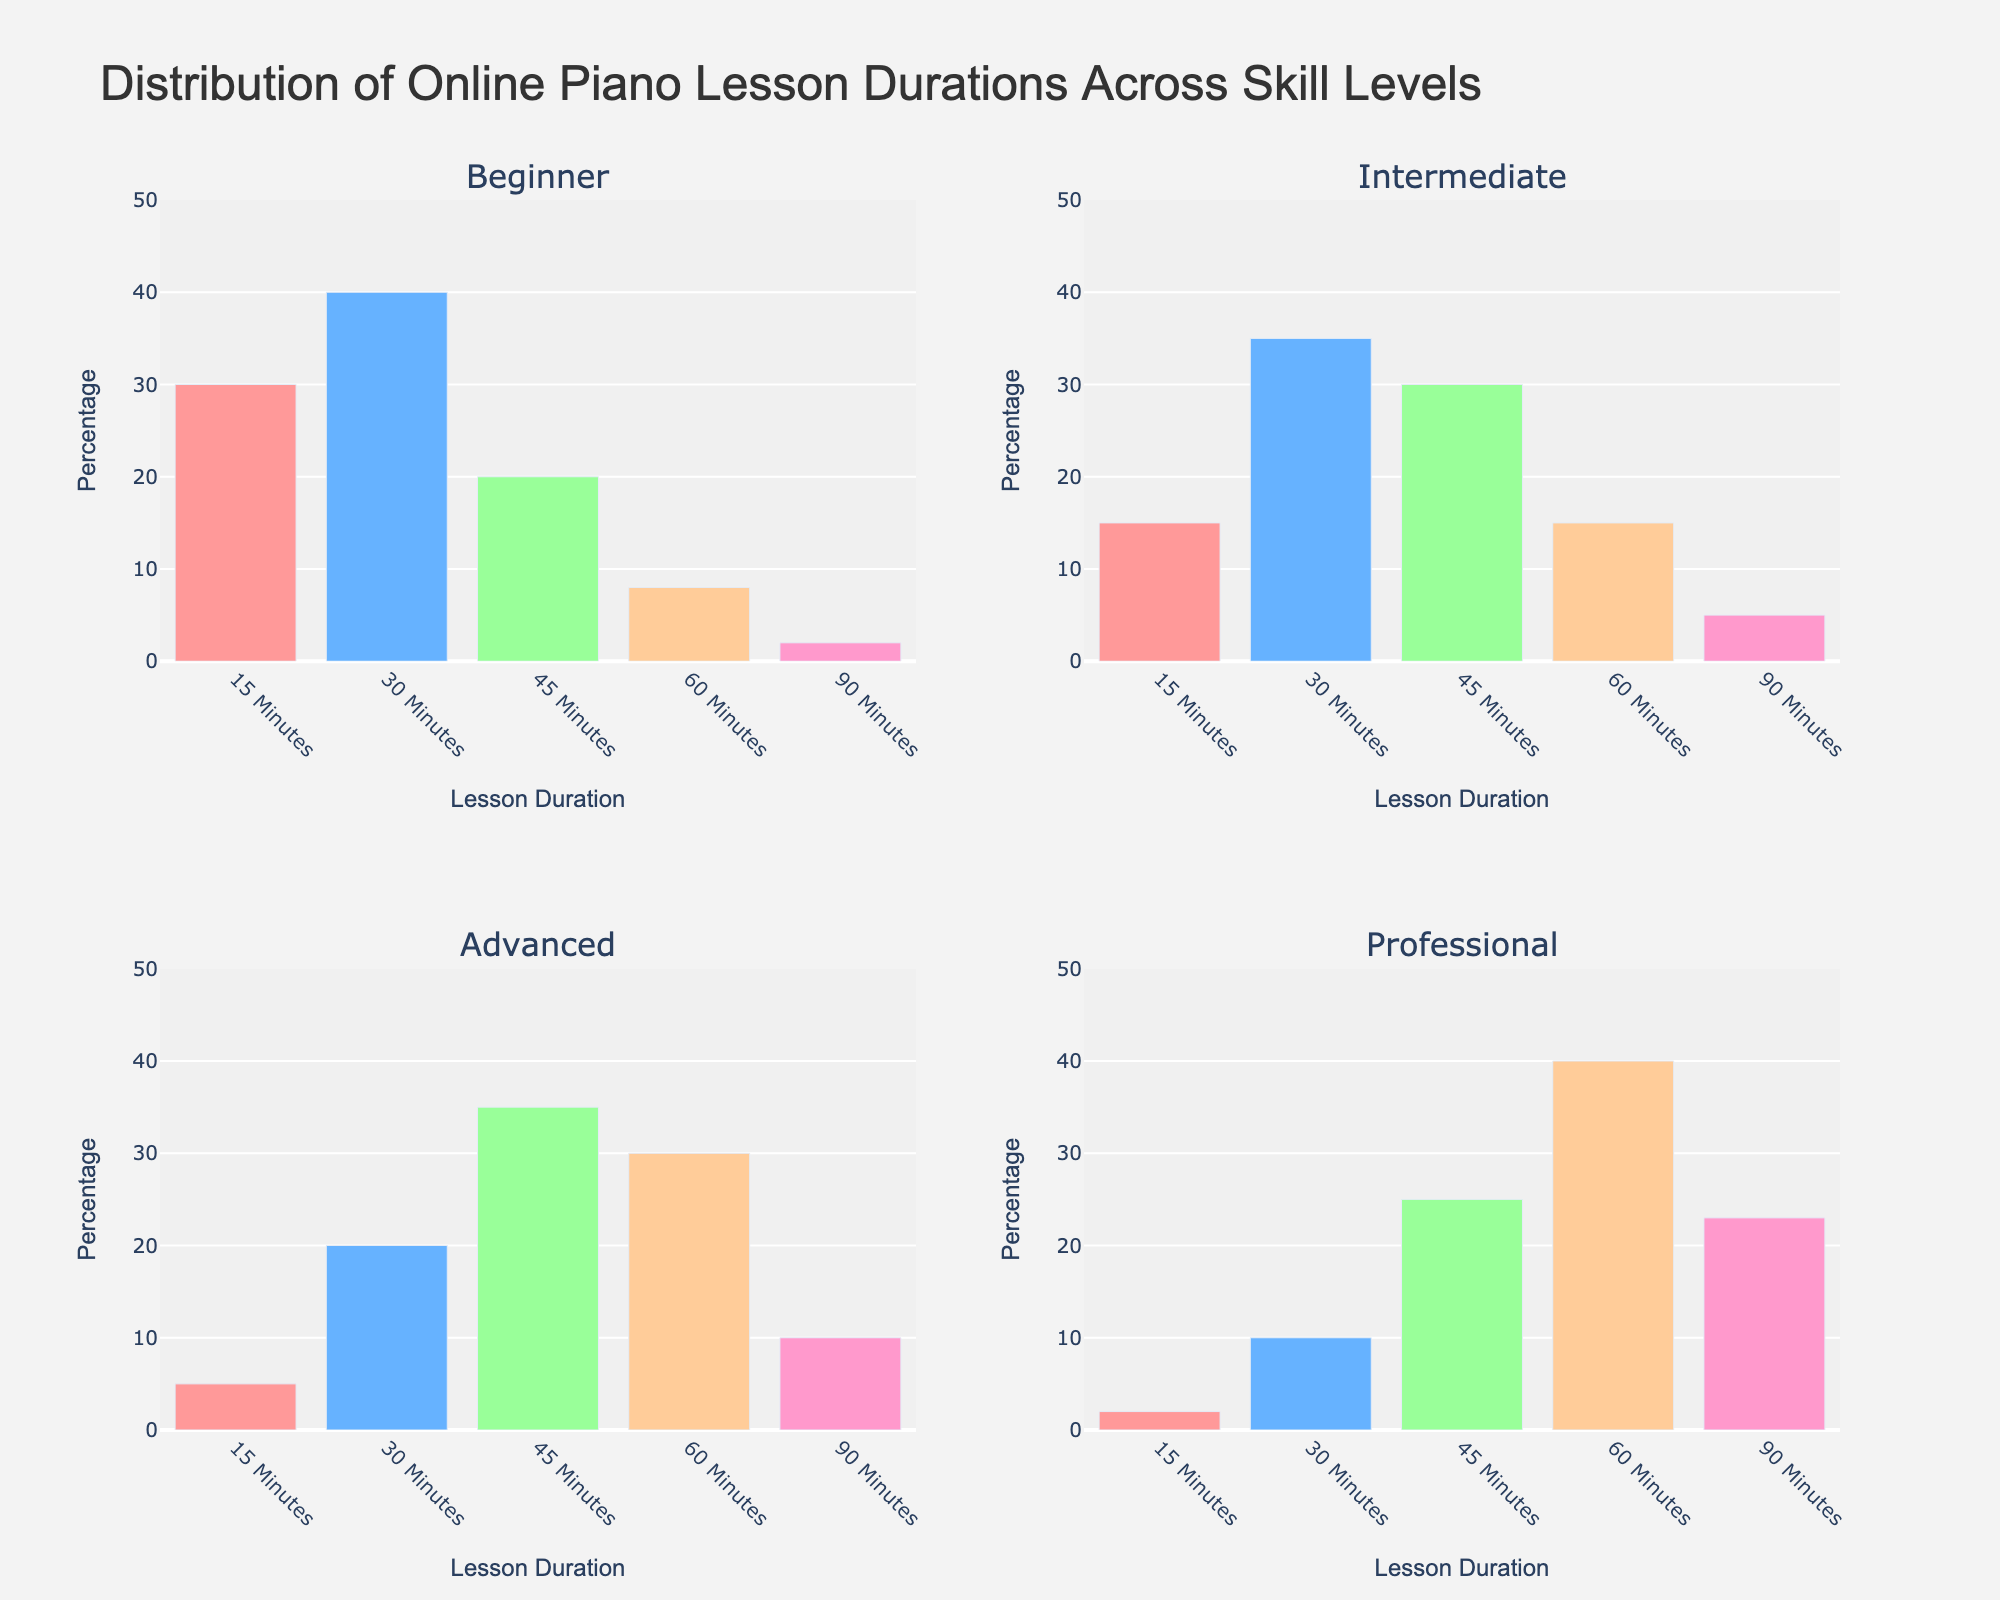What's the title of the figure? The title is displayed at the top center of the figure, usually in a larger font size. It reads "Distribution of Online Piano Lesson Durations Across Skill Levels".
Answer: Distribution of Online Piano Lesson Durations Across Skill Levels Which skill level has the highest percentage attending 45-minute lessons? Look at each subplot for the skill levels and identify the bar corresponding to '45 Minutes'. The tallest bar among them is for 'Advanced' skill level.
Answer: Advanced How many 60-minute lessons are taken by Professionals compared to Beginners? Check the '60 Minutes' bar for both Professionals and Beginners. Beginners have 8%, and Professionals have 40%. Subtract 8% from 40% to find the difference.
Answer: 32% What is the average percentage of lesson durations for Intermediate skill level? Sum the percentages for all lesson durations for Intermediate: 15 + 35 + 30 + 15 + 5 = 100. Then, divide by the number of durations (5). The average is 100/5.
Answer: 20% Which lesson duration does the Beginner skill level attend the least, and how does it compare to the Advanced skill level for the same duration? In the Beginner's subplot, the shortest bar corresponds to '90 Minutes' at 2%. In the Advanced subplot, '90 Minutes' is at 10%. The difference is 10 - 2 = 8%.
Answer: 90 Minutes, 8% Among all the skill levels, which has the most balanced distribution of lesson durations? Look at the subplots and determine which skill level has the most evenly sized bars. Intermediate has values 15, 35, 30, 15, and 5, with less variation among the percentages.
Answer: Intermediate What's the total percentage for 30-minute lessons across all skill levels? Add the values for '30 Minutes' from all subplots: 40 (Beginner) + 35 (Intermediate) + 20 (Advanced) + 10 (Professional) = 105.
Answer: 105% Which skill level shows a greater preference for longer lessons (60 minutes or more) compared to shorter lessons (45 minutes or less)? For each skill level, add the percentages for '60 Minutes' and '90 Minutes', as well as for '15 Minutes', '30 Minutes', and '45 Minutes'. Compare the sums. Professionals have 63% (>45 minutes) vs 12% (<=45 minutes).
Answer: Professional What's the range of 15-minute lessons percentages across all skill levels? Identify the highest (30% from Beginner) and the lowest (2% from Professional) percentages for '15 Minutes' and then find their range by subtracting the lowest from the highest.
Answer: 28% Which lesson duration is most popular for Advanced learners and by how much does this percentage exceed the least popular one? In the Advanced subplot, the highest bar is '45 Minutes' at 35% and the lowest is '15 Minutes' at 5%. Subtract the lowest from the highest to find the difference.
Answer: 45 Minutes, 30% 